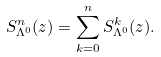Convert formula to latex. <formula><loc_0><loc_0><loc_500><loc_500>S _ { \Lambda ^ { 0 } } ^ { n } ( z ) = \sum _ { k = 0 } ^ { n } S _ { \Lambda ^ { 0 } } ^ { k } ( z ) .</formula> 